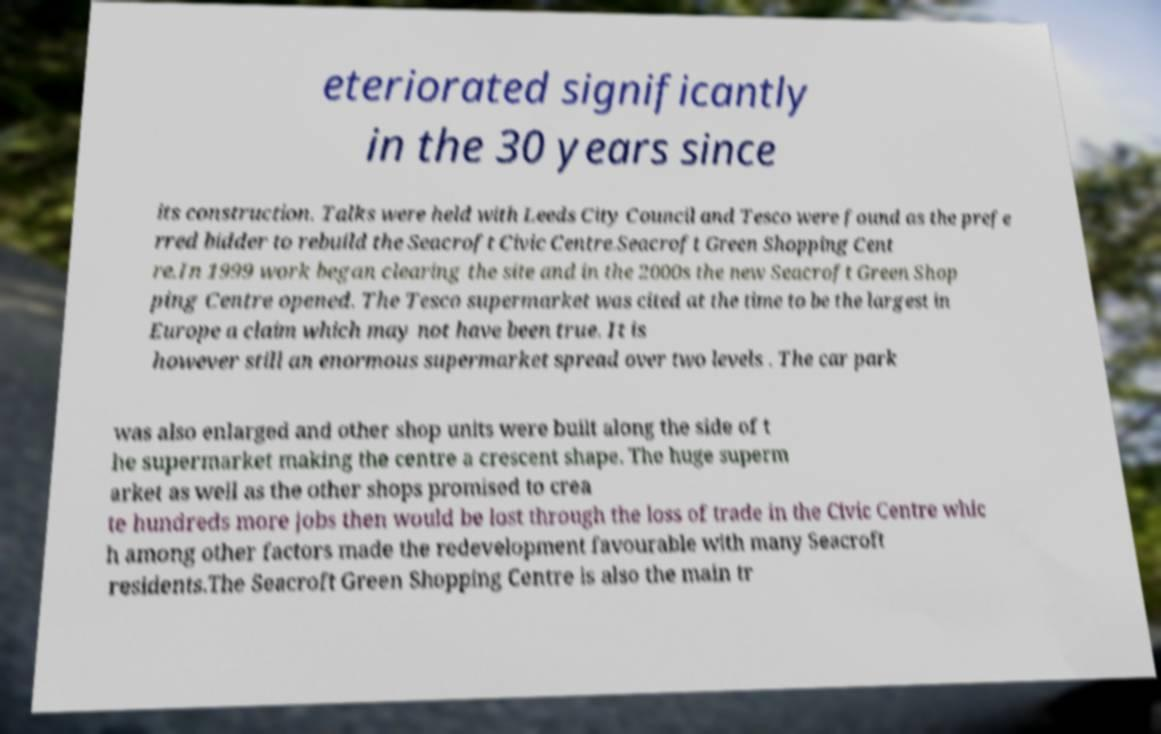There's text embedded in this image that I need extracted. Can you transcribe it verbatim? eteriorated significantly in the 30 years since its construction. Talks were held with Leeds City Council and Tesco were found as the prefe rred bidder to rebuild the Seacroft Civic Centre.Seacroft Green Shopping Cent re.In 1999 work began clearing the site and in the 2000s the new Seacroft Green Shop ping Centre opened. The Tesco supermarket was cited at the time to be the largest in Europe a claim which may not have been true. It is however still an enormous supermarket spread over two levels . The car park was also enlarged and other shop units were built along the side of t he supermarket making the centre a crescent shape. The huge superm arket as well as the other shops promised to crea te hundreds more jobs then would be lost through the loss of trade in the Civic Centre whic h among other factors made the redevelopment favourable with many Seacroft residents.The Seacroft Green Shopping Centre is also the main tr 